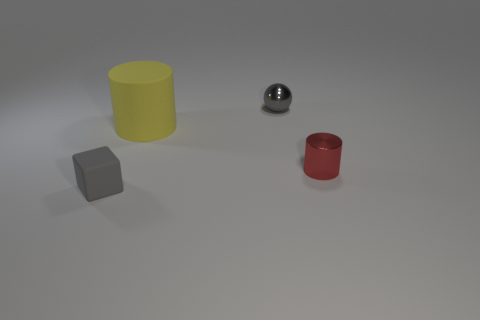Is the color of the small rubber block the same as the tiny shiny ball?
Give a very brief answer. Yes. There is a tiny thing that is the same color as the small metallic ball; what is it made of?
Ensure brevity in your answer.  Rubber. What size is the matte object that is the same color as the small shiny ball?
Provide a succinct answer. Small. Is there any other thing that is the same color as the rubber cube?
Keep it short and to the point. Yes. Is the red thing the same shape as the large matte thing?
Your response must be concise. Yes. What number of large objects are purple matte spheres or rubber things?
Keep it short and to the point. 1. Are there more small gray cubes than large blue cubes?
Provide a succinct answer. Yes. The red thing that is made of the same material as the small sphere is what size?
Offer a terse response. Small. Is the size of the gray thing that is in front of the red metal cylinder the same as the metal thing in front of the gray sphere?
Offer a terse response. Yes. How many objects are tiny shiny objects that are on the right side of the small ball or small blue rubber cylinders?
Make the answer very short. 1. 